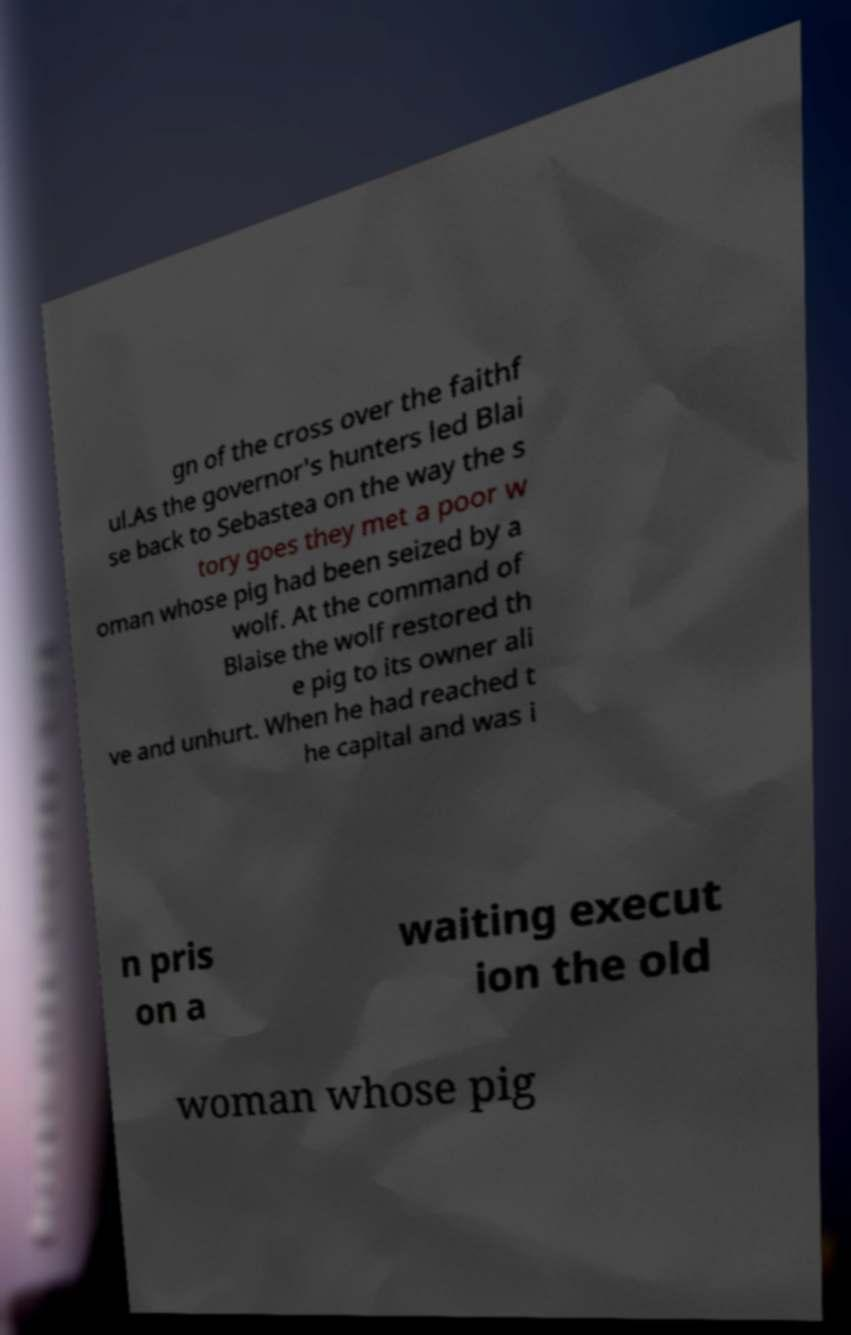I need the written content from this picture converted into text. Can you do that? gn of the cross over the faithf ul.As the governor's hunters led Blai se back to Sebastea on the way the s tory goes they met a poor w oman whose pig had been seized by a wolf. At the command of Blaise the wolf restored th e pig to its owner ali ve and unhurt. When he had reached t he capital and was i n pris on a waiting execut ion the old woman whose pig 